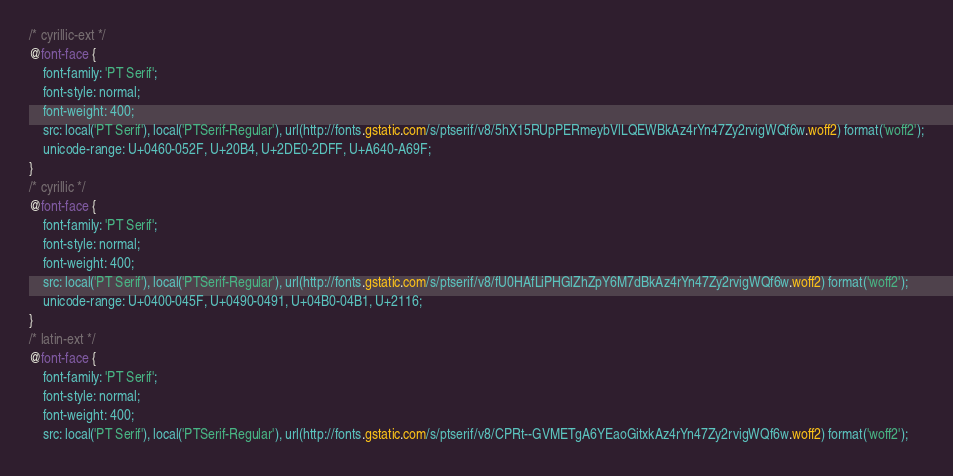<code> <loc_0><loc_0><loc_500><loc_500><_CSS_>/* cyrillic-ext */
@font-face {
    font-family: 'PT Serif';
    font-style: normal;
    font-weight: 400;
    src: local('PT Serif'), local('PTSerif-Regular'), url(http://fonts.gstatic.com/s/ptserif/v8/5hX15RUpPERmeybVlLQEWBkAz4rYn47Zy2rvigWQf6w.woff2) format('woff2');
    unicode-range: U+0460-052F, U+20B4, U+2DE0-2DFF, U+A640-A69F;
}
/* cyrillic */
@font-face {
    font-family: 'PT Serif';
    font-style: normal;
    font-weight: 400;
    src: local('PT Serif'), local('PTSerif-Regular'), url(http://fonts.gstatic.com/s/ptserif/v8/fU0HAfLiPHGlZhZpY6M7dBkAz4rYn47Zy2rvigWQf6w.woff2) format('woff2');
    unicode-range: U+0400-045F, U+0490-0491, U+04B0-04B1, U+2116;
}
/* latin-ext */
@font-face {
    font-family: 'PT Serif';
    font-style: normal;
    font-weight: 400;
    src: local('PT Serif'), local('PTSerif-Regular'), url(http://fonts.gstatic.com/s/ptserif/v8/CPRt--GVMETgA6YEaoGitxkAz4rYn47Zy2rvigWQf6w.woff2) format('woff2');</code> 